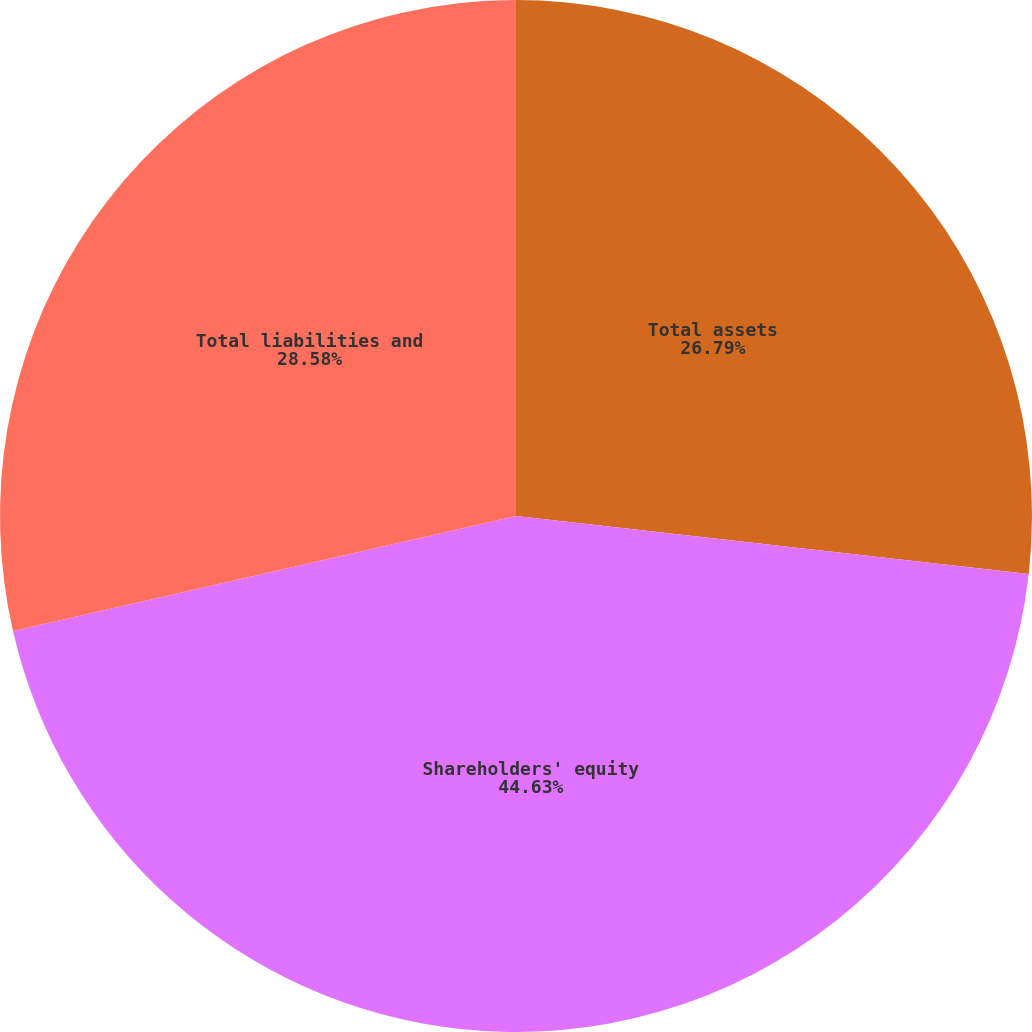<chart> <loc_0><loc_0><loc_500><loc_500><pie_chart><fcel>Total assets<fcel>Shareholders' equity<fcel>Total liabilities and<nl><fcel>26.79%<fcel>44.63%<fcel>28.58%<nl></chart> 